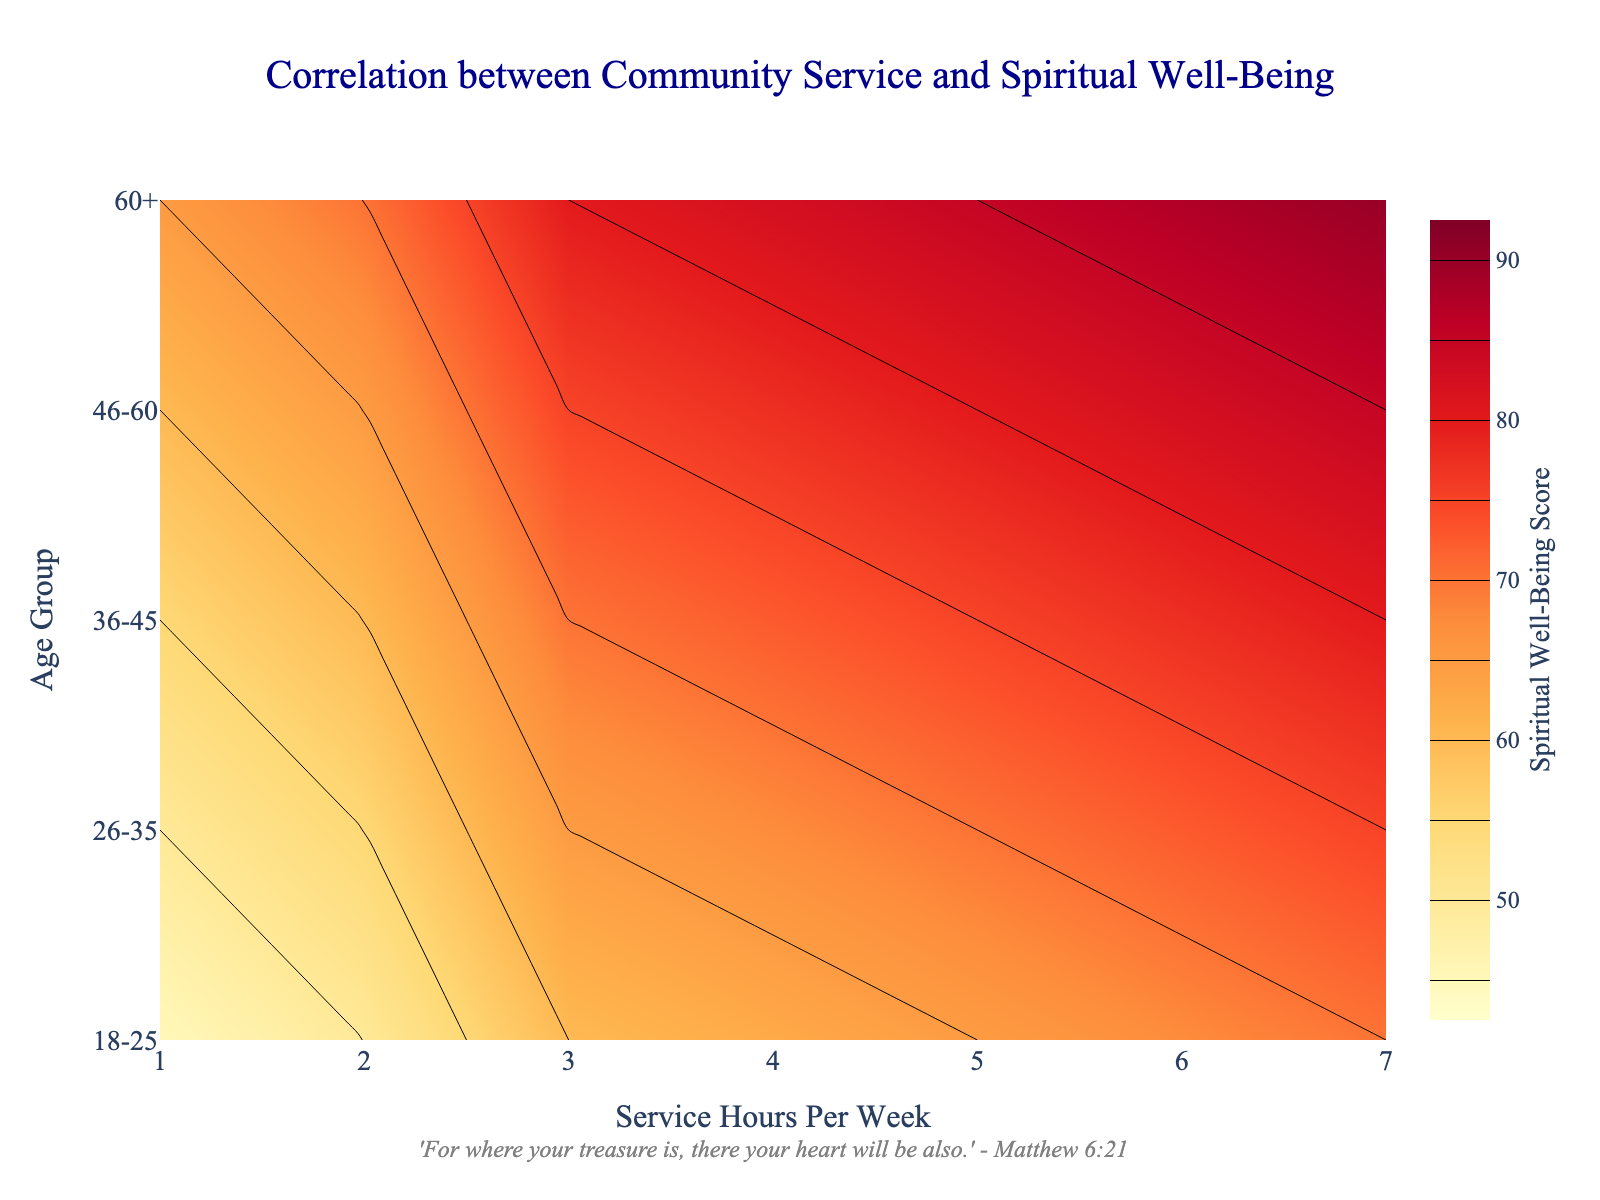Which age group has the highest spiritual well-being score with 5 hours of community service per week? Look at the contour plot and find the scores for 5 hours of community service for each age group. The highest score corresponds to the age group "60+."
Answer: 60+ What is the interval of the spiritual well-being scores shown on the color bar? Examine the color bar on the right side. It starts at 45 and ends at 90, indicating the range of scores.
Answer: 45 to 90 How does the spiritual well-being score change for the 36-45 age group as service hours increase from 1 to 7 per week? Trace the contour lines for the 36-45 age group from 1 to 7 service hours per week. The scores progressively increase from 55 to 80.
Answer: Increases from 55 to 80 Compare the spiritual well-being scores between the 18-25 and 46-60 age groups at 3 hours of service per week. Locate the scores for both age groups at 3 hours of service. The 18-25 age group has a score of 60, while the 46-60 age group has a score of 75.
Answer: 18-25 has 60, 46-60 has 75 What is the title of the plotted figure? The title is displayed at the top of the figure.
Answer: Correlation between Community Service and Spiritual Well-Being Identify the axis representing the service hours per week. The x-axis at the bottom of the plot shows the service hours per week.
Answer: x-axis Determine the average spiritual well-being score for the 26-35 age group. Find the scores for the 26-35 age group: 50, 55, 65, 70, and 75. The average is calculated as (50 + 55 + 65 + 70 + 75) / 5 = 63.
Answer: 63 Explain the contour color change as the spiritual well-being score increases. Colors transition from light yellow to deep red as the scores increase, indicating a higher spiritual well-being score.
Answer: Light yellow to deep red 